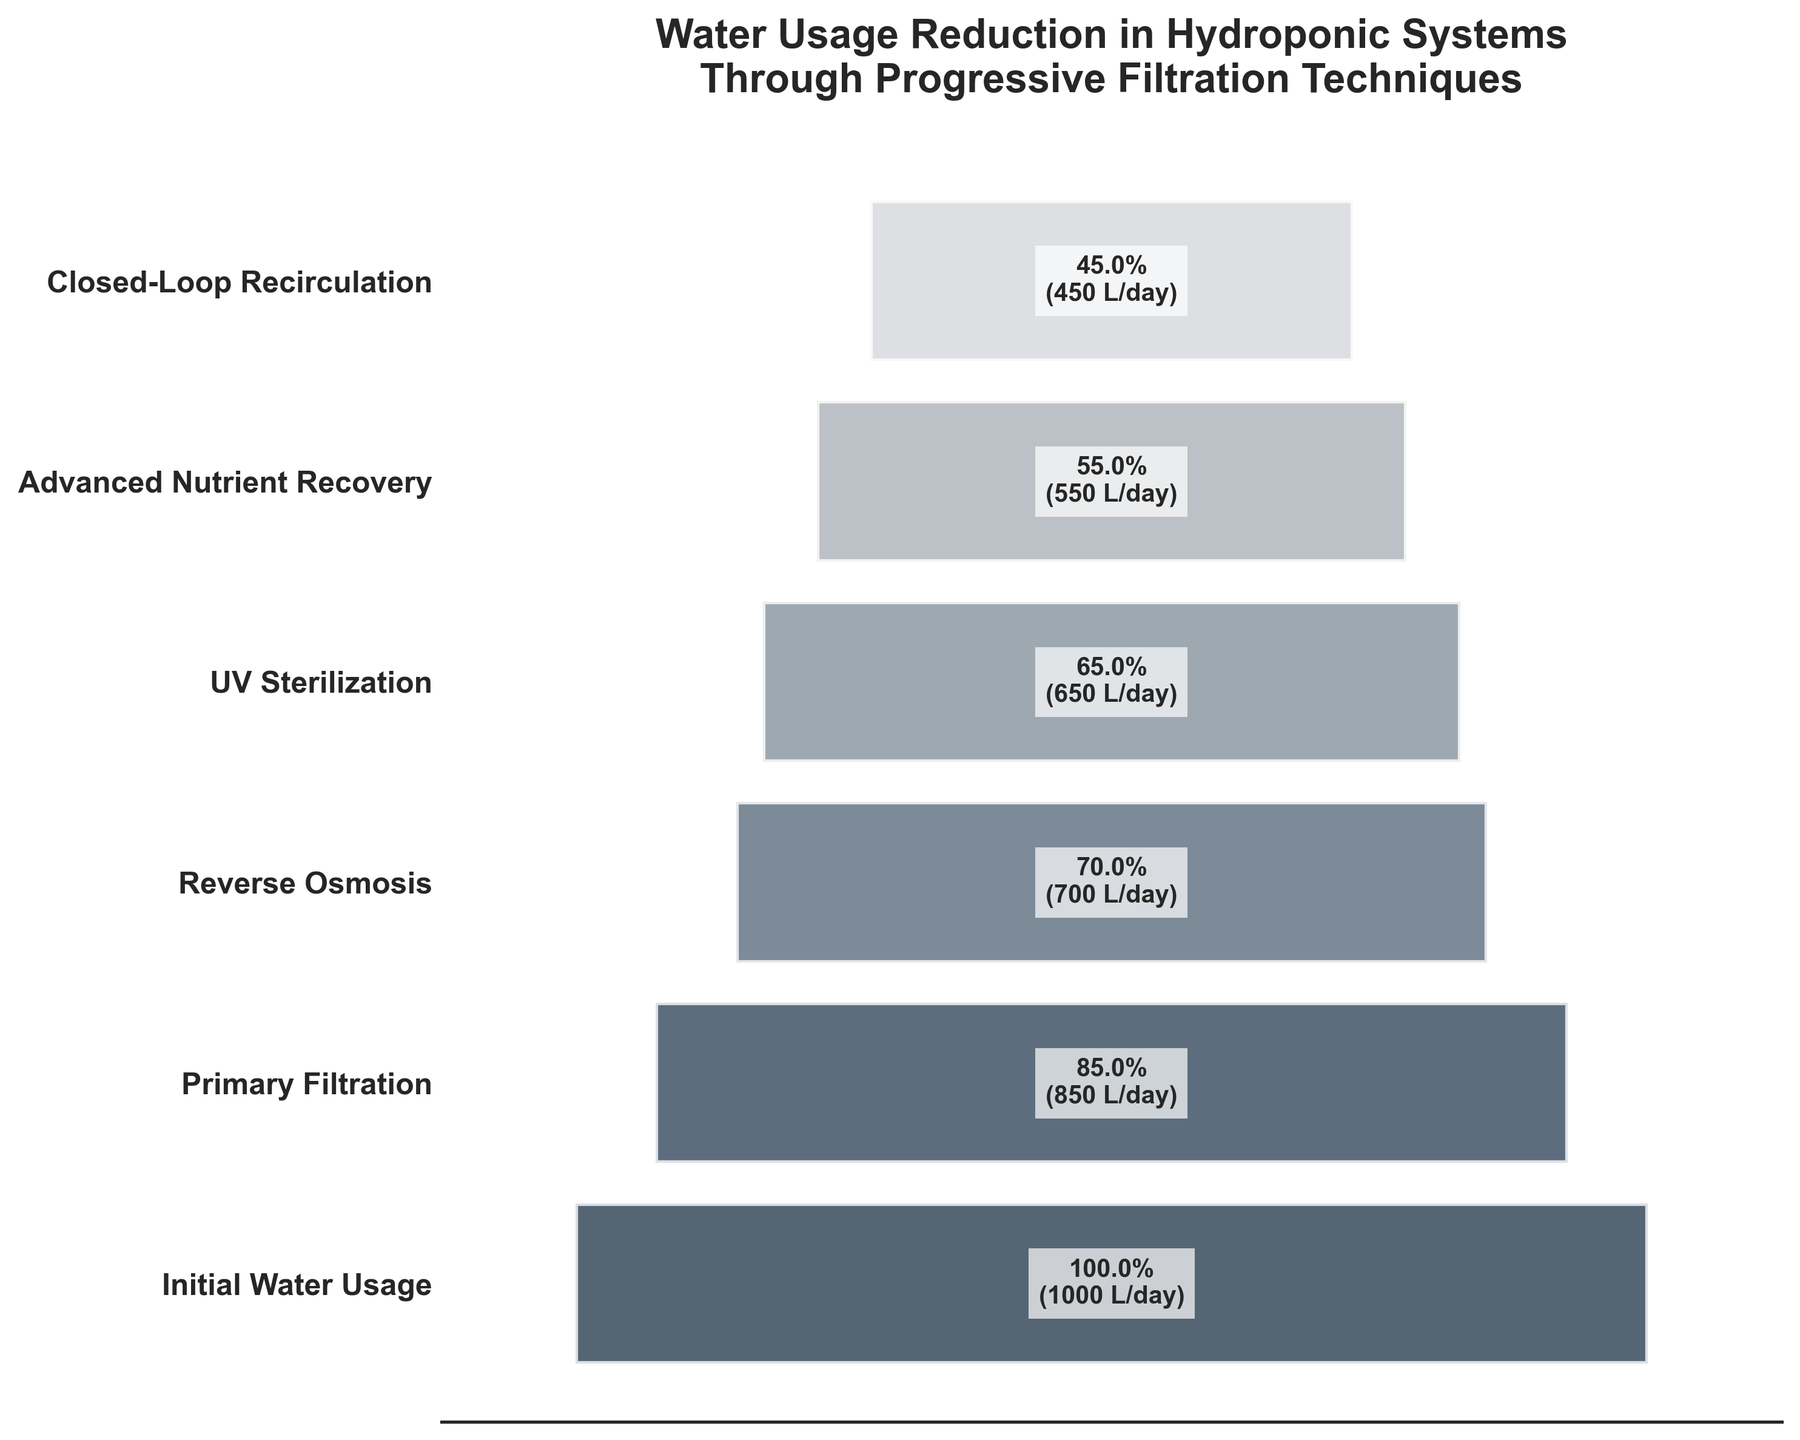Which stage has the highest water usage reduction? The stage with the highest water usage reduction is determined by the difference between the initial water usage and the water usage after that stage. The greatest reduction is from the Initial Water Usage to Primary Filtration, which is 1000 - 850 = 150 liters/day.
Answer: Primary Filtration What's the percentage reduction in water usage after Reverse Osmosis compared to the Initial Water Usage? The percentage reduction after Reverse Osmosis is calculated by comparing the water usage at that stage to the Initial Water Usage. The water usage after Reverse Osmosis is 700 liters/day, and the Initial Water Usage is 1000 liters/day. The reduction percentage is: ((1000 - 700) / 1000) * 100 = 30%.
Answer: 30% By how many liters does water usage reduce between Advanced Nutrient Recovery and Closed-Loop Recirculation? The reduction in water usage between Advanced Nutrient Recovery and Closed-Loop Recirculation is found by subtracting the latter's usage from the former's: 550 - 450 = 100 liters/day.
Answer: 100 liters/day At which stage is the water usage closest to 50% of the initial usage? The stage closest to using 50% of the initial water usage (1000 liters/day) is examined by comparing the stages' water usage to 500 liters/day. Advanced Nutrient Recovery, at 550 liters/day, is nearest.
Answer: Advanced Nutrient Recovery What is the highest water usage recorded after applying any filtration technique? After the Initial Water Usage, the highest recorded water usage post-filtration is found at the Primary Filtration stage, which is 850 liters/day.
Answer: Primary Filtration How much water is saved after implementing UV Sterilization? The water saved after UV Sterilization is calculated by subtracting the water usage post-UV Sterilization from the Initial Water Usage: 1000 - 650 = 350 liters/day.
Answer: 350 liters/day What are the total liters/day saved if all filtration techniques are implemented? The total water saved by implementing all techniques is calculated by the difference between the Initial Water Usage and the final stage (Closed-Loop Recirculation): 1000 - 450 = 550 liters/day.
Answer: 550 liters/day Which stage in the filtration process shows the smallest reduction in water usage? The smallest reduction in water usage is determined by finding the stage with the smallest difference from the previous stage. The smallest reduction occurs between Reverse Osmosis and UV Sterilization, which is 700 - 650 = 50 liters/day.
Answer: UV Sterilization 